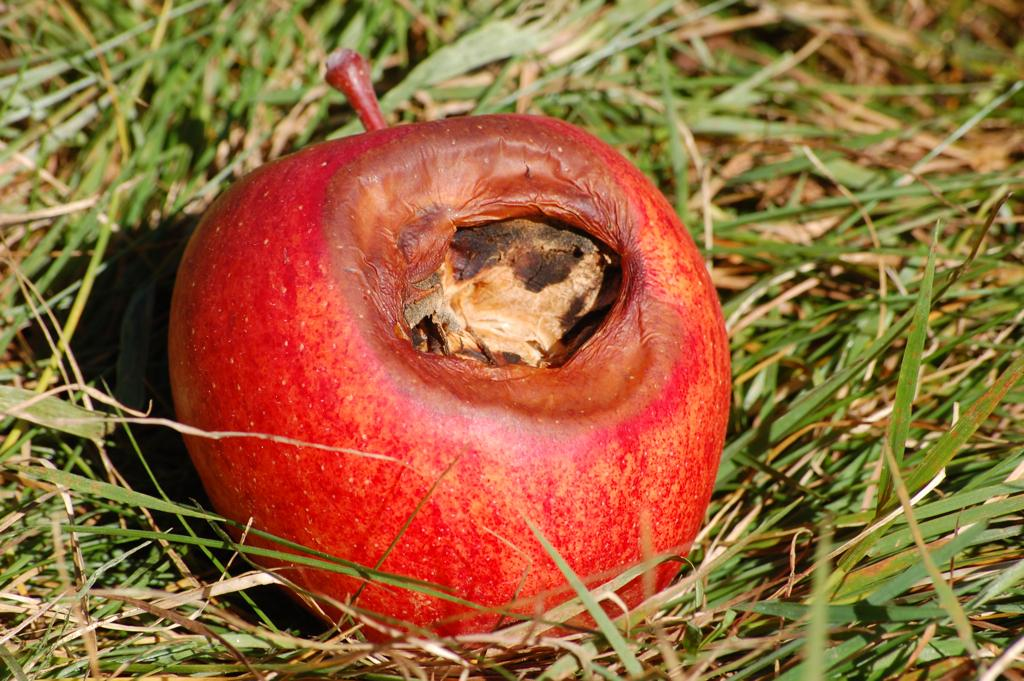What is the main subject of the image? The main subject of the image is an apple. Where is the apple located in the image? The apple is in the center of the image. What is the surface on which the apple is placed? The apple is on the grass. What type of family gathering is taking place in the image? There is no family gathering present in the image; it only features an apple on the grass. Where is the lunchroom located in the image? There is no lunchroom present in the image; it only features an apple on the grass. 